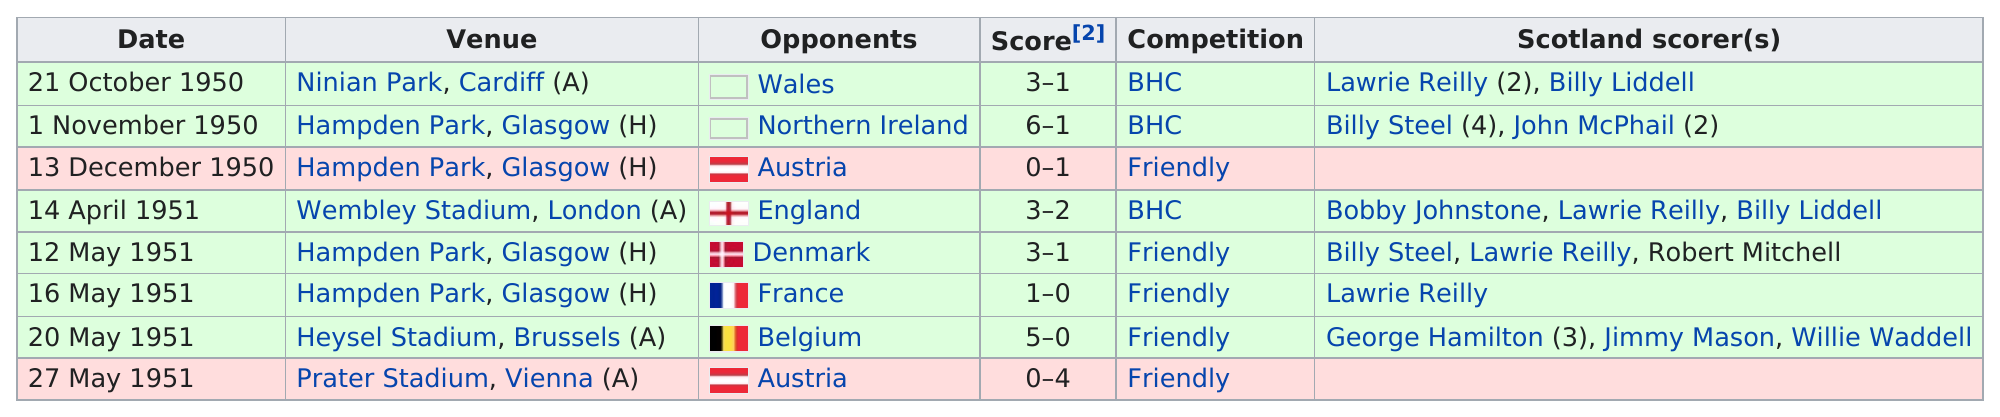Mention a couple of crucial points in this snapshot. Billy Steel led the Scotland national team in goals scored during the 1950 British Home Championship. Scotland did not have any scorers against Austria, who was their opponent in a match. Scotland played their first match of the 1951 British Home Championship against England, marking the beginning of a significant sporting event. On May 20th, 1951, no goals were scored by the Belgium national team. In the game between Belgium and George Hamilton in 1951, George Hamilton scored the larger number of goals. 